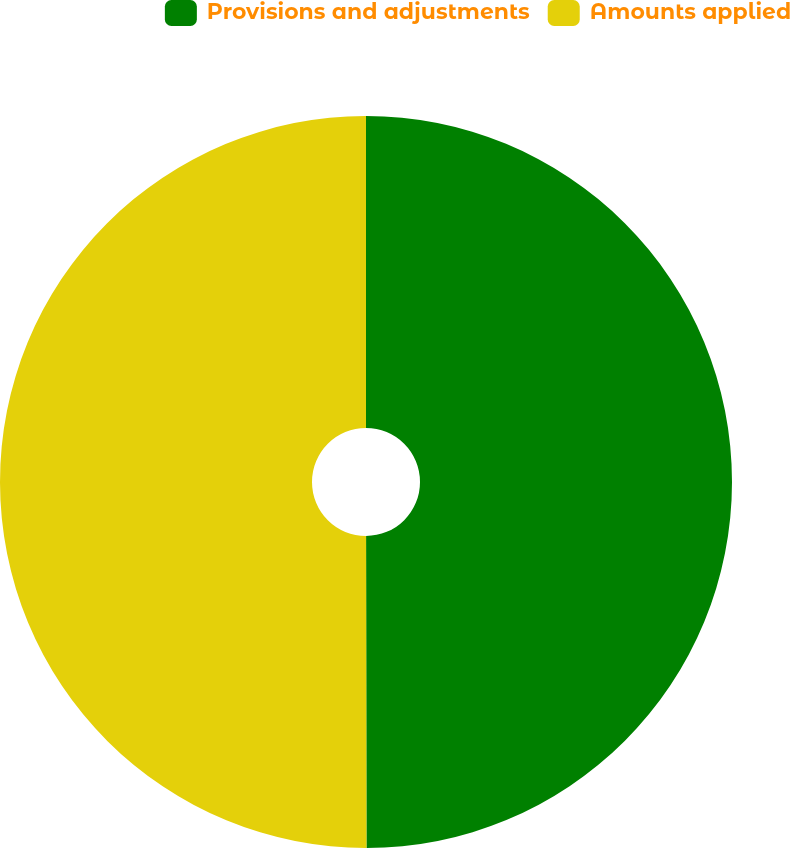Convert chart to OTSL. <chart><loc_0><loc_0><loc_500><loc_500><pie_chart><fcel>Provisions and adjustments<fcel>Amounts applied<nl><fcel>49.98%<fcel>50.02%<nl></chart> 